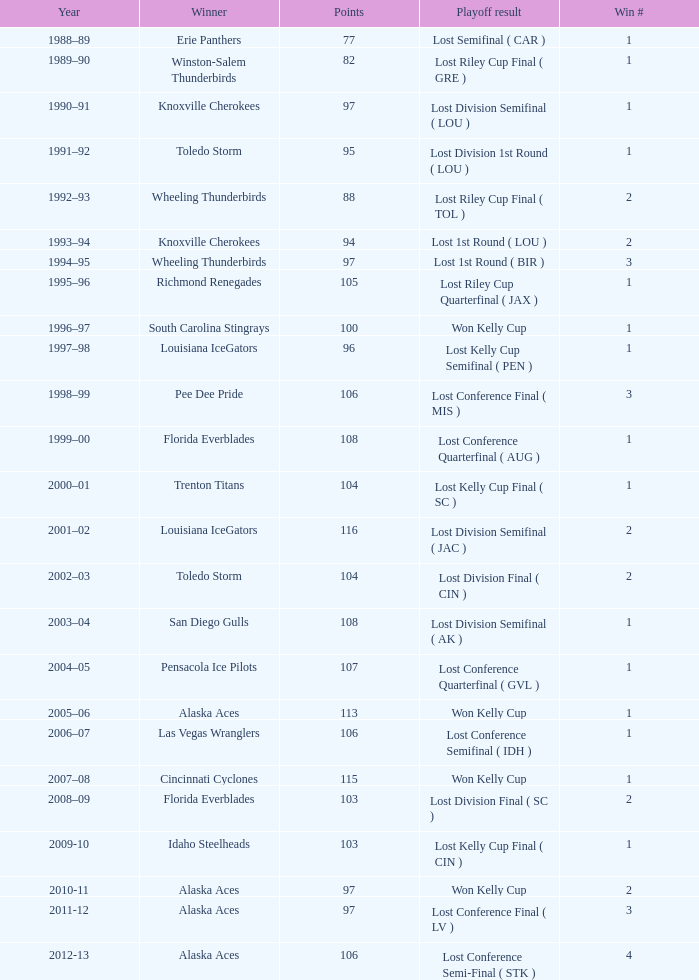Could you help me parse every detail presented in this table? {'header': ['Year', 'Winner', 'Points', 'Playoff result', 'Win #'], 'rows': [['1988–89', 'Erie Panthers', '77', 'Lost Semifinal ( CAR )', '1'], ['1989–90', 'Winston-Salem Thunderbirds', '82', 'Lost Riley Cup Final ( GRE )', '1'], ['1990–91', 'Knoxville Cherokees', '97', 'Lost Division Semifinal ( LOU )', '1'], ['1991–92', 'Toledo Storm', '95', 'Lost Division 1st Round ( LOU )', '1'], ['1992–93', 'Wheeling Thunderbirds', '88', 'Lost Riley Cup Final ( TOL )', '2'], ['1993–94', 'Knoxville Cherokees', '94', 'Lost 1st Round ( LOU )', '2'], ['1994–95', 'Wheeling Thunderbirds', '97', 'Lost 1st Round ( BIR )', '3'], ['1995–96', 'Richmond Renegades', '105', 'Lost Riley Cup Quarterfinal ( JAX )', '1'], ['1996–97', 'South Carolina Stingrays', '100', 'Won Kelly Cup', '1'], ['1997–98', 'Louisiana IceGators', '96', 'Lost Kelly Cup Semifinal ( PEN )', '1'], ['1998–99', 'Pee Dee Pride', '106', 'Lost Conference Final ( MIS )', '3'], ['1999–00', 'Florida Everblades', '108', 'Lost Conference Quarterfinal ( AUG )', '1'], ['2000–01', 'Trenton Titans', '104', 'Lost Kelly Cup Final ( SC )', '1'], ['2001–02', 'Louisiana IceGators', '116', 'Lost Division Semifinal ( JAC )', '2'], ['2002–03', 'Toledo Storm', '104', 'Lost Division Final ( CIN )', '2'], ['2003–04', 'San Diego Gulls', '108', 'Lost Division Semifinal ( AK )', '1'], ['2004–05', 'Pensacola Ice Pilots', '107', 'Lost Conference Quarterfinal ( GVL )', '1'], ['2005–06', 'Alaska Aces', '113', 'Won Kelly Cup', '1'], ['2006–07', 'Las Vegas Wranglers', '106', 'Lost Conference Semifinal ( IDH )', '1'], ['2007–08', 'Cincinnati Cyclones', '115', 'Won Kelly Cup', '1'], ['2008–09', 'Florida Everblades', '103', 'Lost Division Final ( SC )', '2'], ['2009-10', 'Idaho Steelheads', '103', 'Lost Kelly Cup Final ( CIN )', '1'], ['2010-11', 'Alaska Aces', '97', 'Won Kelly Cup', '2'], ['2011-12', 'Alaska Aces', '97', 'Lost Conference Final ( LV )', '3'], ['2012-13', 'Alaska Aces', '106', 'Lost Conference Semi-Final ( STK )', '4']]} What is the victor when victory number is more than 1, and when scores are below 94? Wheeling Thunderbirds. 